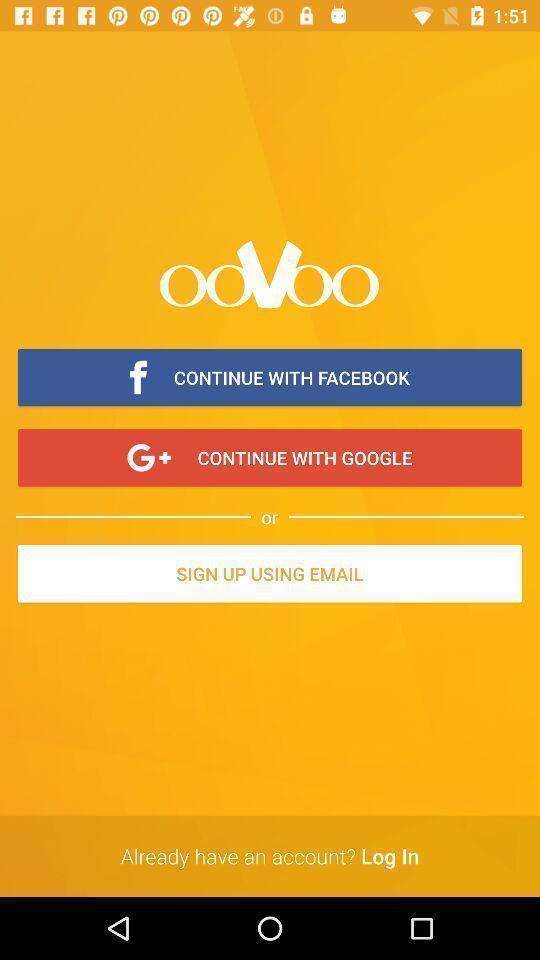Give me a summary of this screen capture. Welcome page of a social application. 